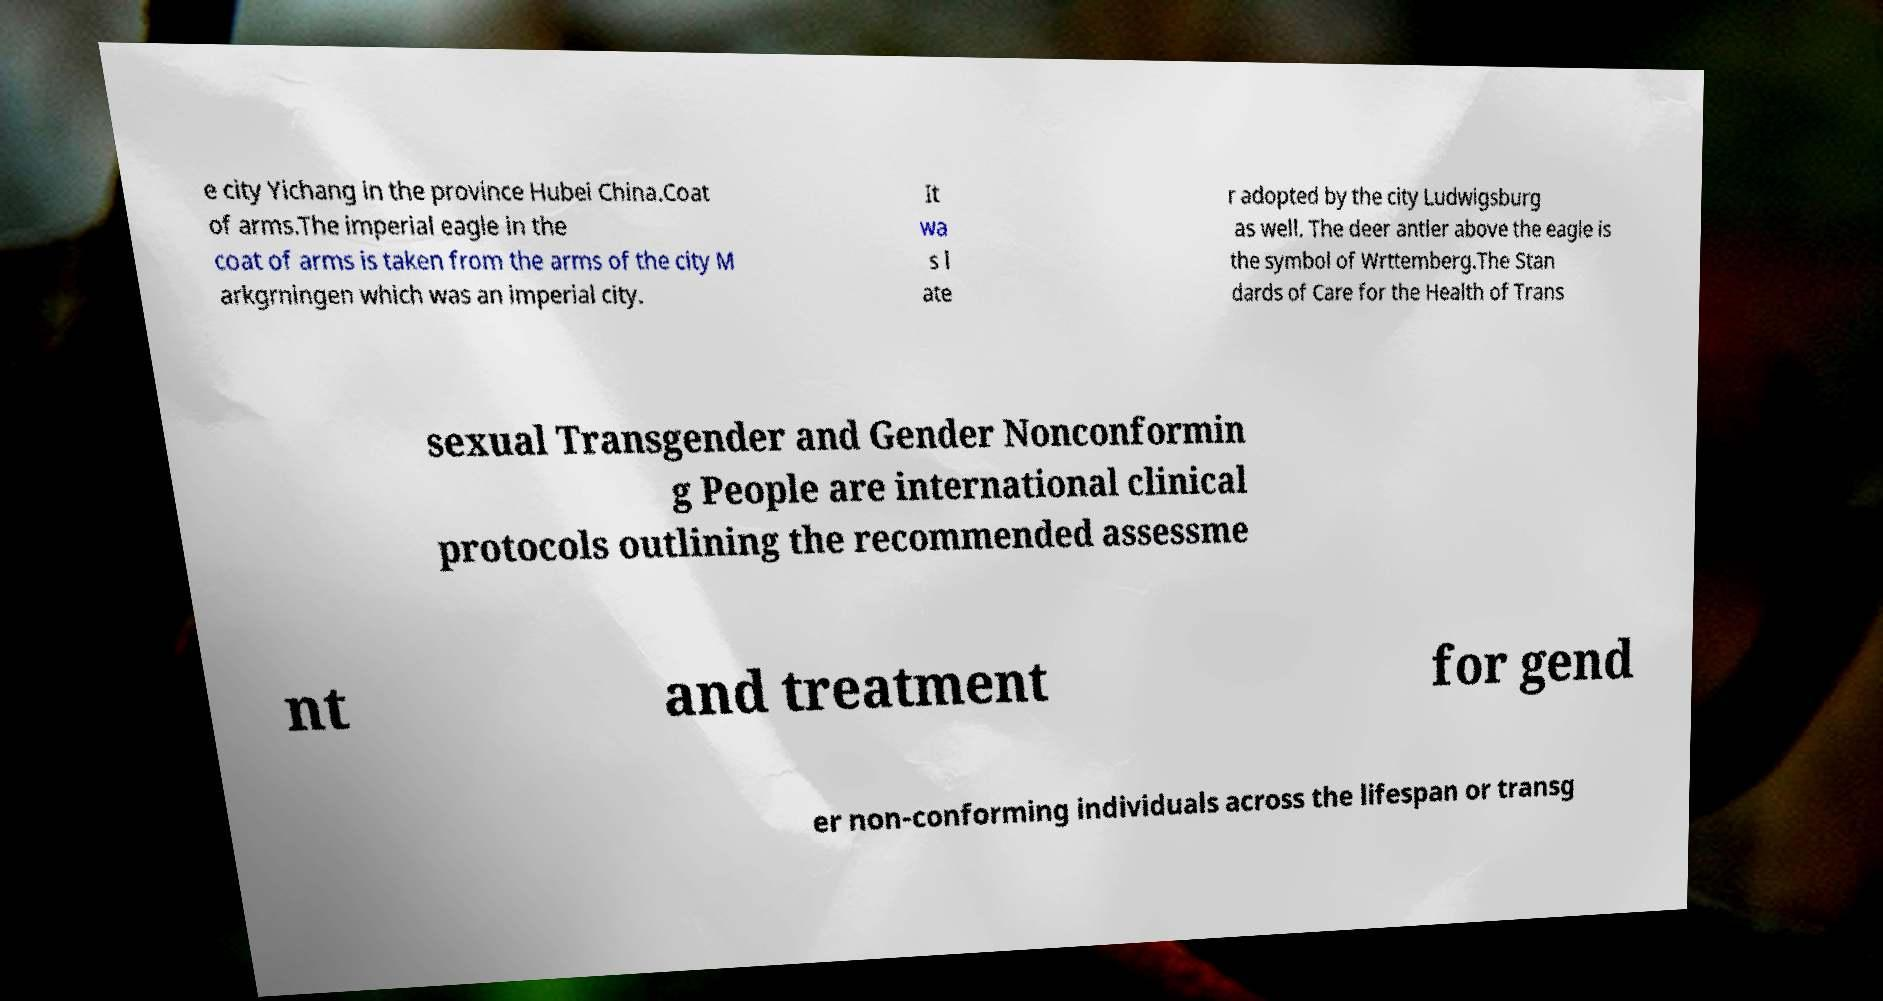For documentation purposes, I need the text within this image transcribed. Could you provide that? e city Yichang in the province Hubei China.Coat of arms.The imperial eagle in the coat of arms is taken from the arms of the city M arkgrningen which was an imperial city. It wa s l ate r adopted by the city Ludwigsburg as well. The deer antler above the eagle is the symbol of Wrttemberg.The Stan dards of Care for the Health of Trans sexual Transgender and Gender Nonconformin g People are international clinical protocols outlining the recommended assessme nt and treatment for gend er non-conforming individuals across the lifespan or transg 